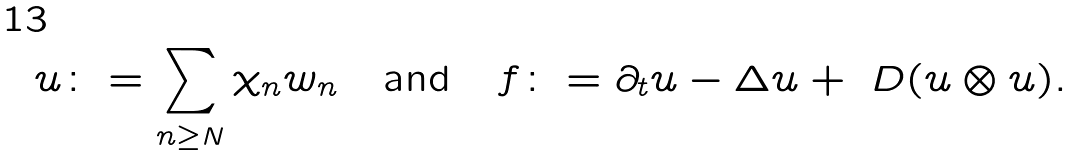Convert formula to latex. <formula><loc_0><loc_0><loc_500><loc_500>u \colon = \sum _ { n \geq N } \chi _ { n } w _ { n } \quad \text {and} \quad f \colon = \partial _ { t } u - \Delta u + \ D ( u \otimes u ) .</formula> 